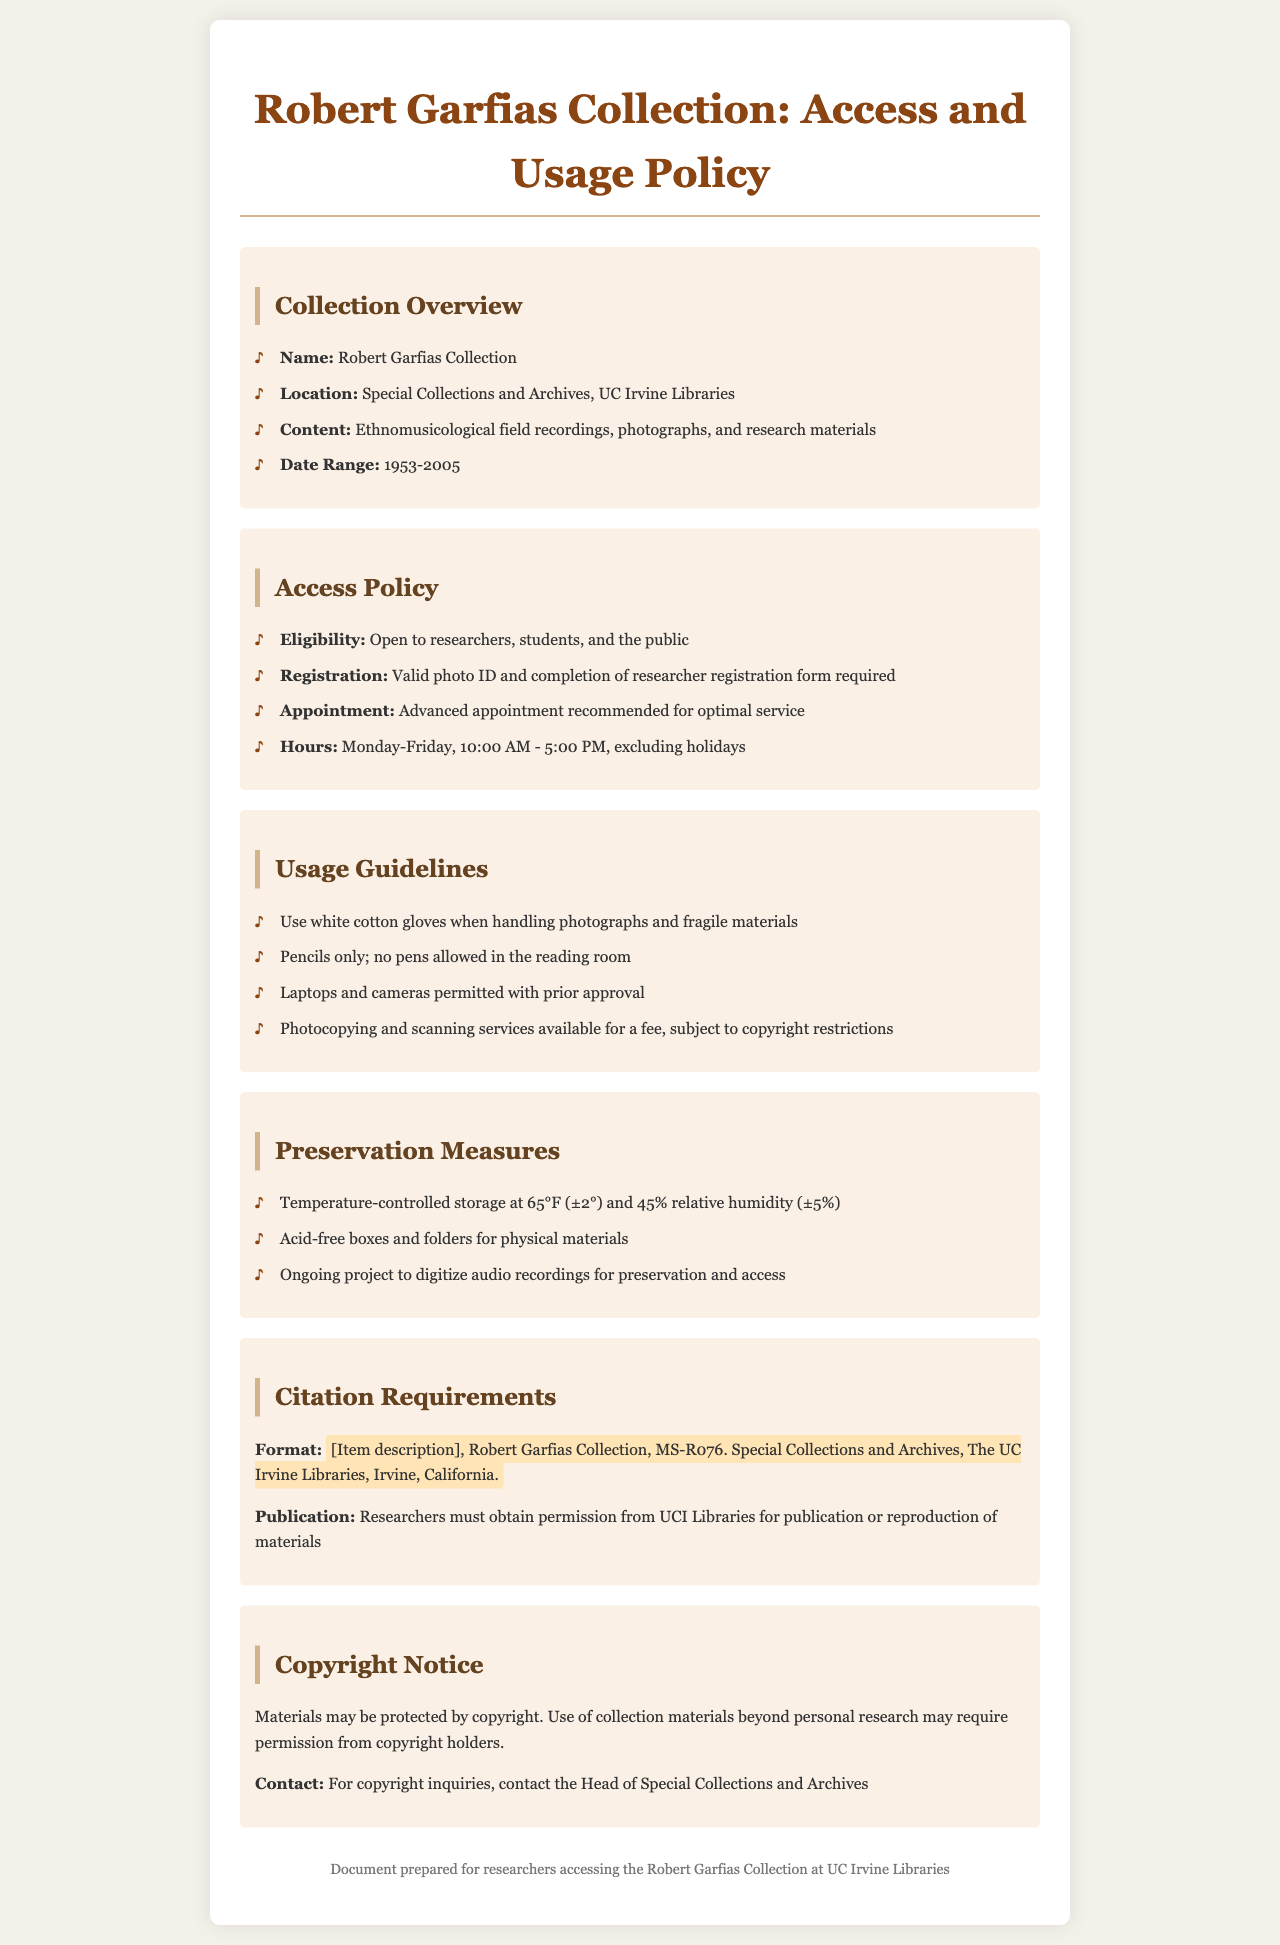What is the name of the collection? The document lists the name of the collection as "Robert Garfias Collection."
Answer: Robert Garfias Collection Where is the collection located? The location of the collection is specified as "Special Collections and Archives, UC Irvine Libraries."
Answer: Special Collections and Archives, UC Irvine Libraries What is the date range of the collection? The date range provided in the document is from 1953 to 2005.
Answer: 1953-2005 What is required for registration? The document specifies that a valid photo ID and completion of a researcher registration form are required for registration.
Answer: Valid photo ID and completion of researcher registration form What temperature is used for storage? The preservation measures state that the storage temperature is maintained at 65°F (±2°).
Answer: 65°F (±2°) Why is an advanced appointment recommended? The document suggests that an advanced appointment is recommended "for optimal service," indicating a reasoning for efficiency.
Answer: For optimal service What is the citation format for materials? The document outlines a specific citation format which includes an item description and collection details.
Answer: [Item description], Robert Garfias Collection, MS-R076. Special Collections and Archives, The UC Irvine Libraries, Irvine, California What must researchers obtain for publication? The policy states researchers must obtain "permission from UCI Libraries for publication or reproduction of materials."
Answer: Permission from UCI Libraries What is the allowed writing tool in the reading room? The document specifies that "pencils only; no pens allowed in the reading room."
Answer: Pencils only 